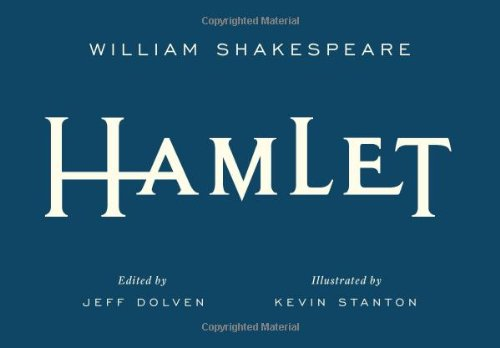Can you describe the themes explored in this book? 'Hamlet' explores profound themes such as existential angst, the complexity of life and death, madness, and political intrigue. 